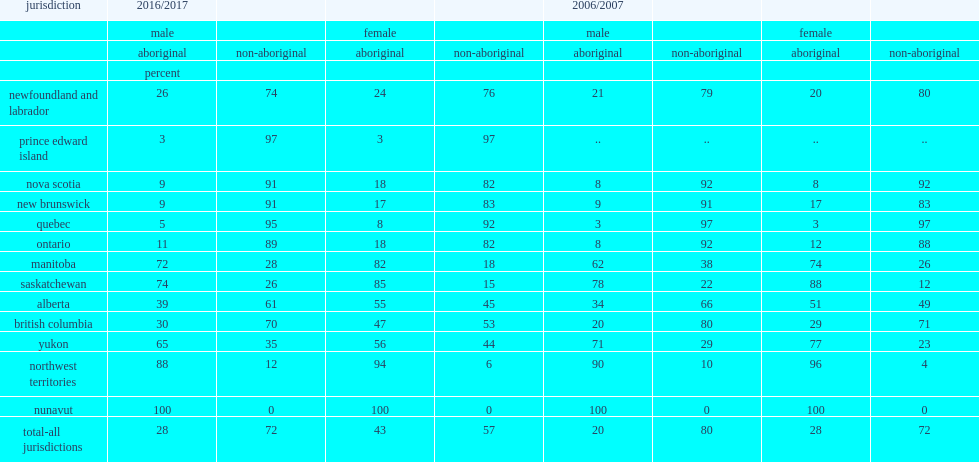How many percent did aboriginal males account for admissions to custody in the province and territories in 2016/2017? 28.0. How many percent did non-aboriginal males account for admissions to custody in the province and territories in 2016/2017? 72.0. How many percent did aboriginal females account for admissions to custody in the province and territories in 2016/2017? 43.0. How many percent did non-aboriginal females account for admissions to custody in the province and territories in 2016/2017? 57.0. 